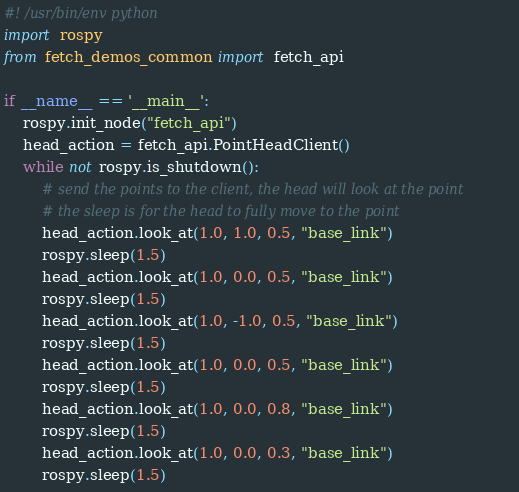<code> <loc_0><loc_0><loc_500><loc_500><_Python_>#! /usr/bin/env python
import rospy
from fetch_demos_common import fetch_api

if __name__ == '__main__':
    rospy.init_node("fetch_api")
    head_action = fetch_api.PointHeadClient()
    while not rospy.is_shutdown():
        # send the points to the client, the head will look at the point 
        # the sleep is for the head to fully move to the point 
        head_action.look_at(1.0, 1.0, 0.5, "base_link")
        rospy.sleep(1.5)
        head_action.look_at(1.0, 0.0, 0.5, "base_link")
        rospy.sleep(1.5)
        head_action.look_at(1.0, -1.0, 0.5, "base_link")
        rospy.sleep(1.5)
        head_action.look_at(1.0, 0.0, 0.5, "base_link")
        rospy.sleep(1.5)
        head_action.look_at(1.0, 0.0, 0.8, "base_link")
        rospy.sleep(1.5)
        head_action.look_at(1.0, 0.0, 0.3, "base_link")
        rospy.sleep(1.5)</code> 